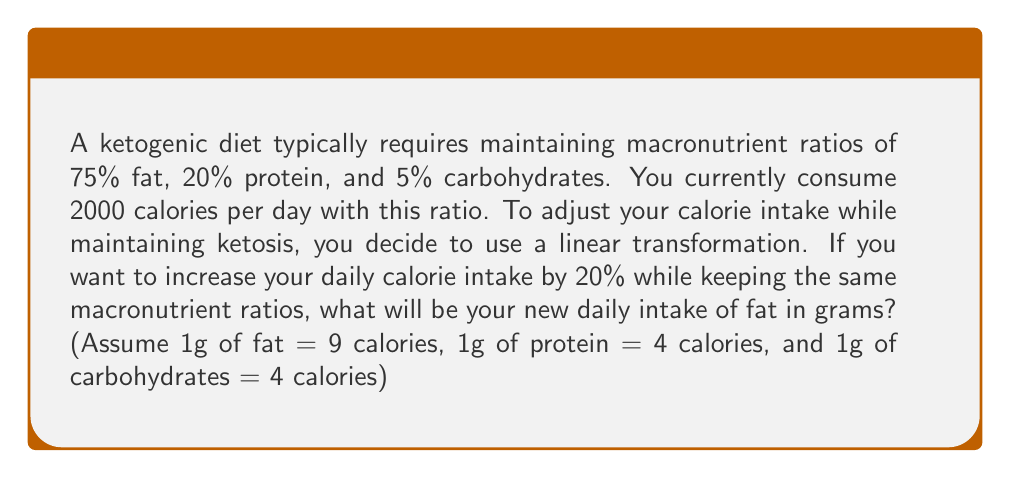Can you answer this question? Let's approach this step-by-step:

1) First, let's calculate the current macronutrient intake in calories:
   Fat: $0.75 \times 2000 = 1500$ calories
   Protein: $0.20 \times 2000 = 400$ calories
   Carbs: $0.05 \times 2000 = 100$ calories

2) Now, let's set up our linear transformation. We want to increase everything by 20%, so our transformation matrix will be:

   $$T = \begin{pmatrix} 1.2 & 0 & 0 \\ 0 & 1.2 & 0 \\ 0 & 0 & 1.2 \end{pmatrix}$$

3) Let's apply this transformation to our current calorie intake:

   $$\begin{pmatrix} 1.2 & 0 & 0 \\ 0 & 1.2 & 0 \\ 0 & 0 & 1.2 \end{pmatrix} \begin{pmatrix} 1500 \\ 400 \\ 100 \end{pmatrix} = \begin{pmatrix} 1800 \\ 480 \\ 120 \end{pmatrix}$$

4) So our new calorie intake from fat is 1800 calories.

5) To convert this to grams, we divide by 9 (since 1g of fat = 9 calories):

   $$1800 \div 9 = 200$$

Therefore, the new daily intake of fat will be 200 grams.
Answer: 200 grams 